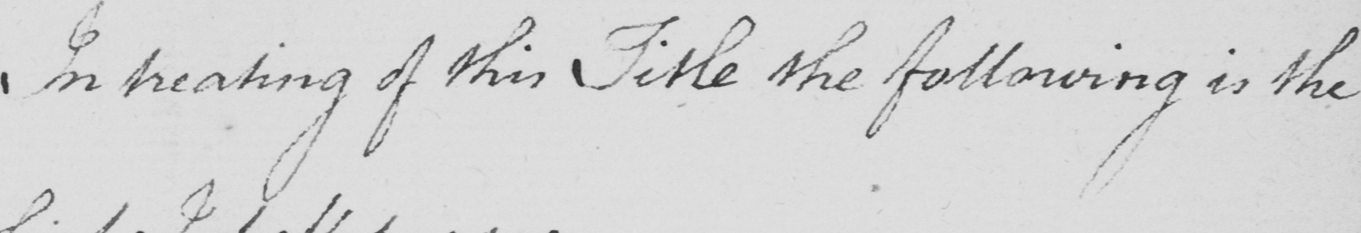Please provide the text content of this handwritten line. In treating of this Title the following is the 